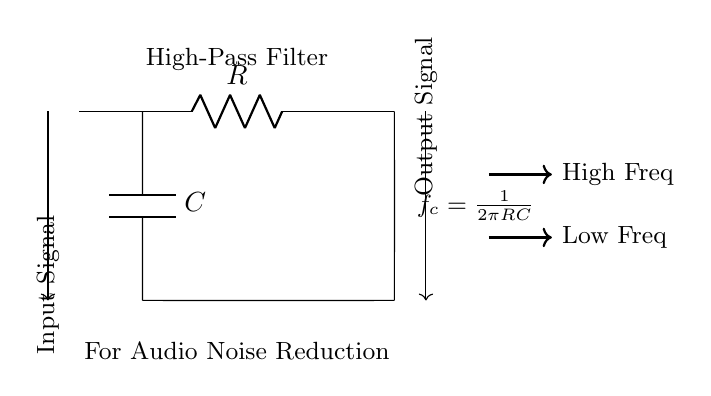What is the type of filter represented in this circuit? The circuit is labeled as a "High-Pass Filter," which indicates its function to allow high-frequency signals to pass while attenuating low-frequency signals.
Answer: High-Pass Filter What are the components used in this filter circuit? The circuit diagram displays two main components: a resistor denoted as "R" and a capacitor denoted as "C". These components are typically used in RC circuits, specifically in this high-pass filter configuration.
Answer: R and C What do the arrows in the circuit indicate? The arrows illustrate the direction of signal flow through the circuit. One arrow points toward the input signifying where the audio signal enters, and the other arrow indicates the output where the processed signal exits the circuit.
Answer: Direction of signal flow What is the formula for the cutoff frequency in this circuit? The formula shown in the circuit is "f_c = 1/(2πRC)", which defines the cutoff frequency of the high-pass filter based on the resistor and capacitor values. This frequency denotes the threshold above which signals are allowed to pass.
Answer: 1/(2πRC) What happens to low-frequency signals in this circuit? Since this is a high-pass filter, low-frequency signals are significantly attenuated or reduced when they pass through the circuit, leading to a decrease in their amplitude at the output. This design helps eliminate unwanted noise in audio applications.
Answer: Attenuated How does the circuit behave with high-frequency input signals? High-frequency signals are allowed to pass through with minimal attenuation. The high-pass filter allows these signals to reach the output with a higher amplitude compared to the low-frequency signals, effectively reducing noise interference.
Answer: Passes with minimal attenuation 